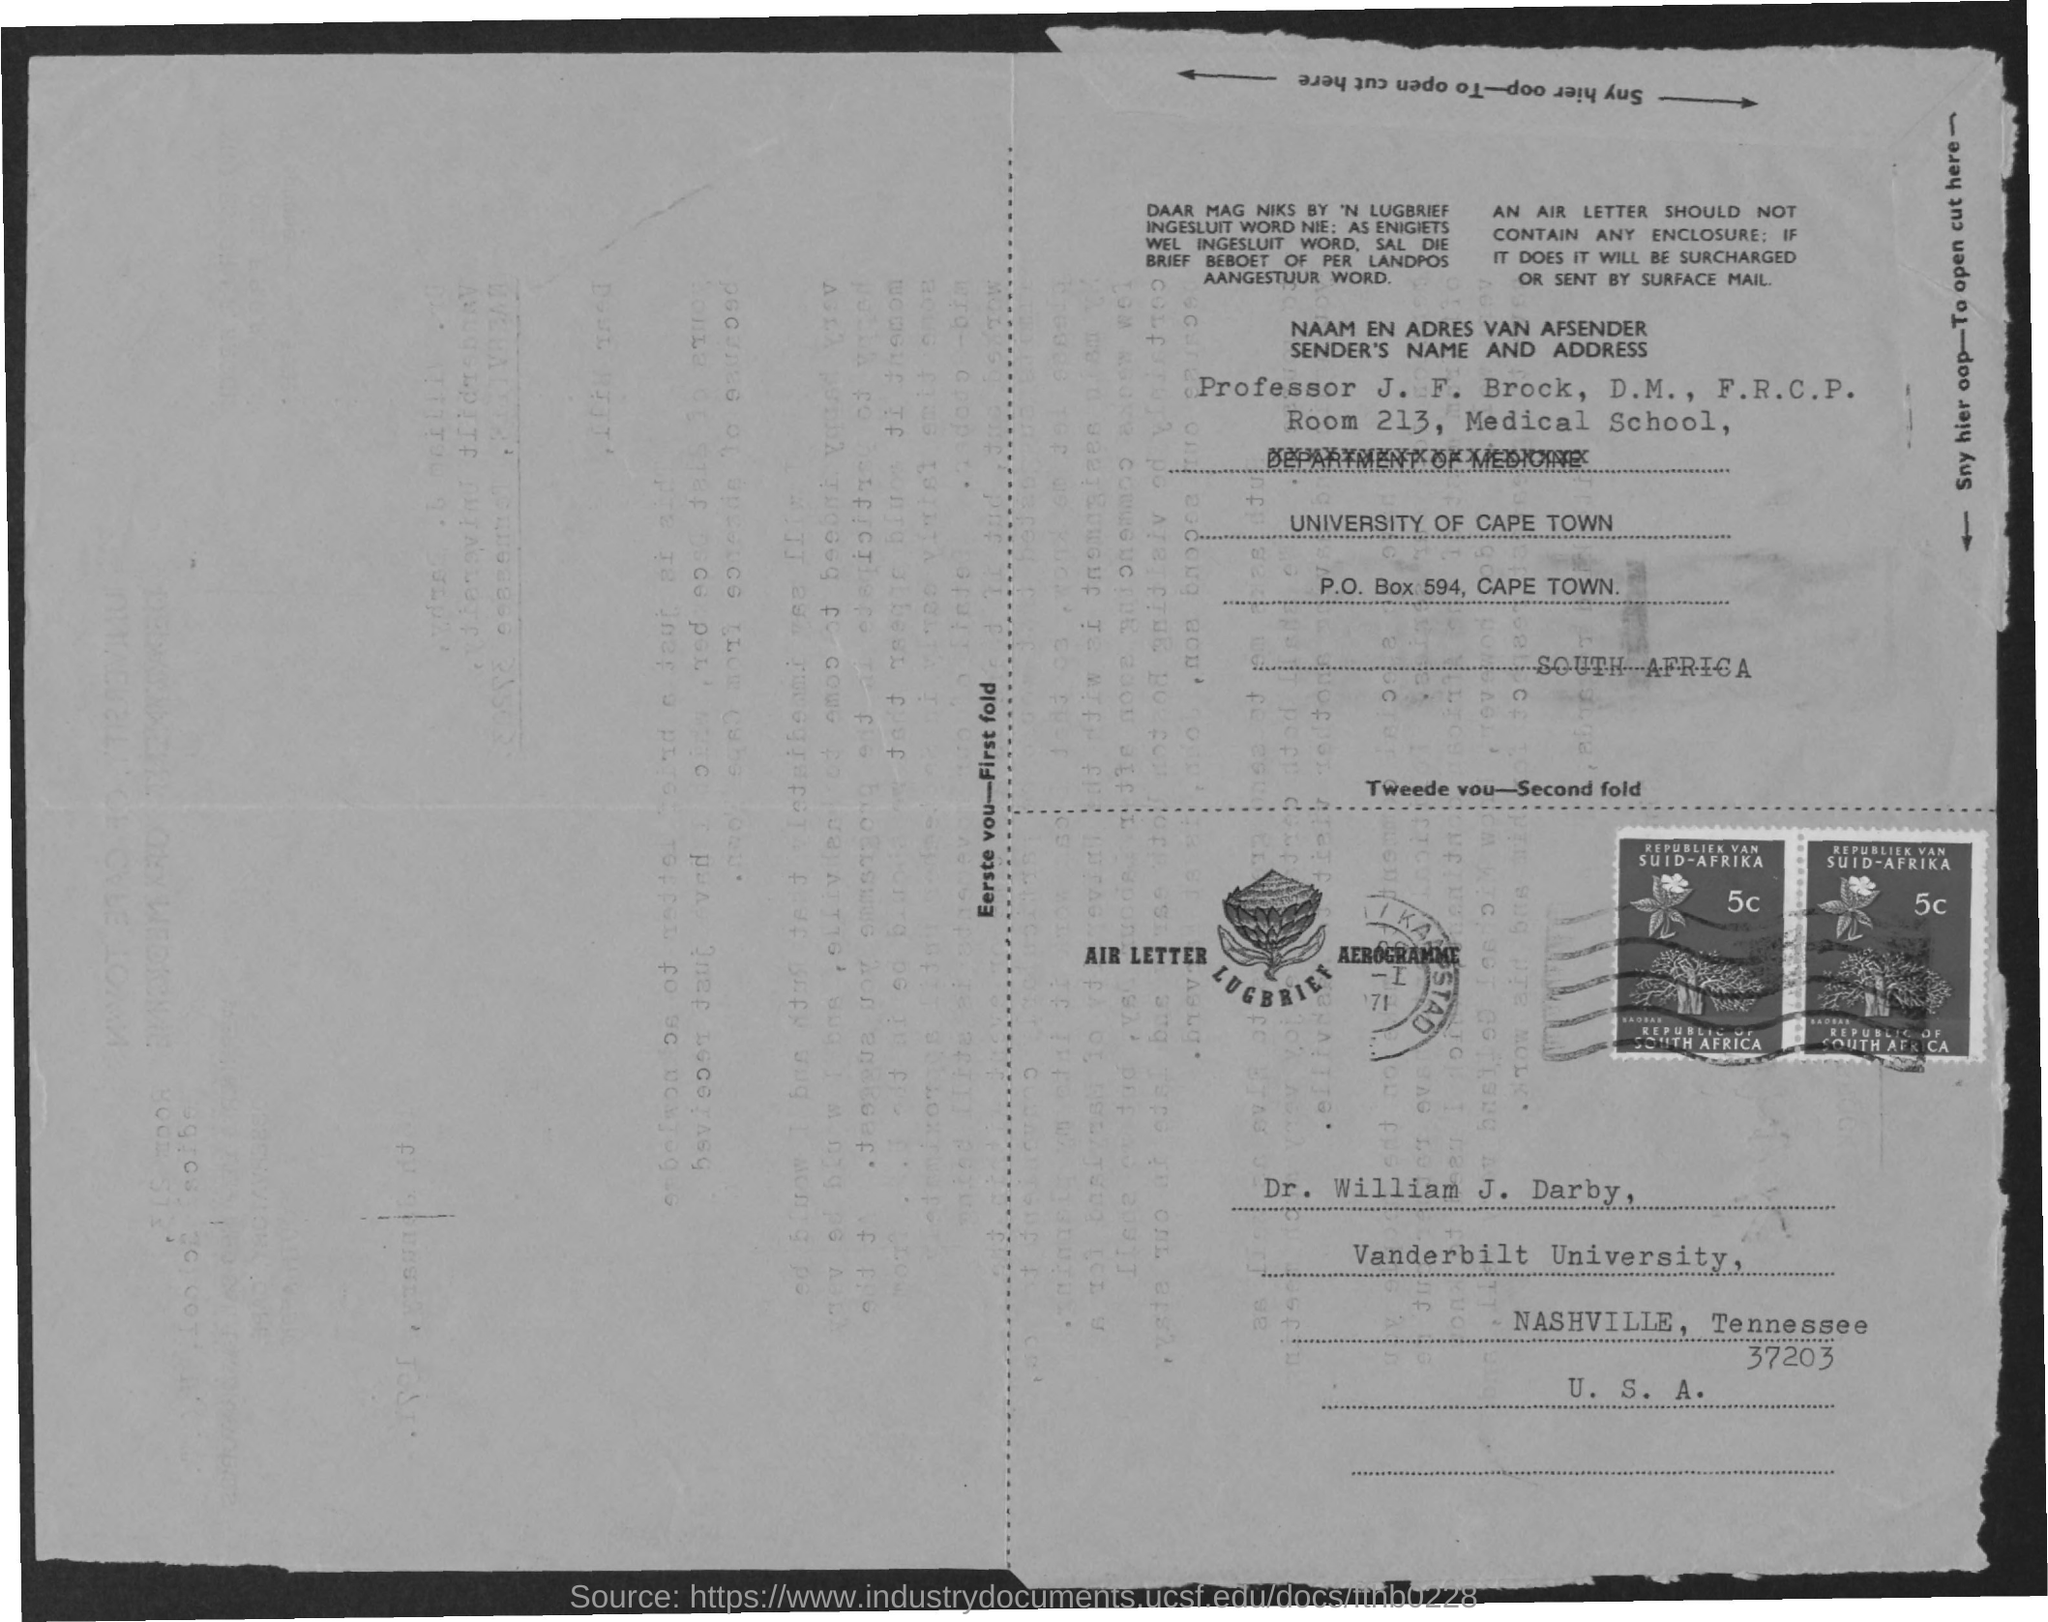Identify some key points in this picture. Dr. William J. Darby is from Vanderbilt University. The letter is addressed to Dr. William J. Darby. 